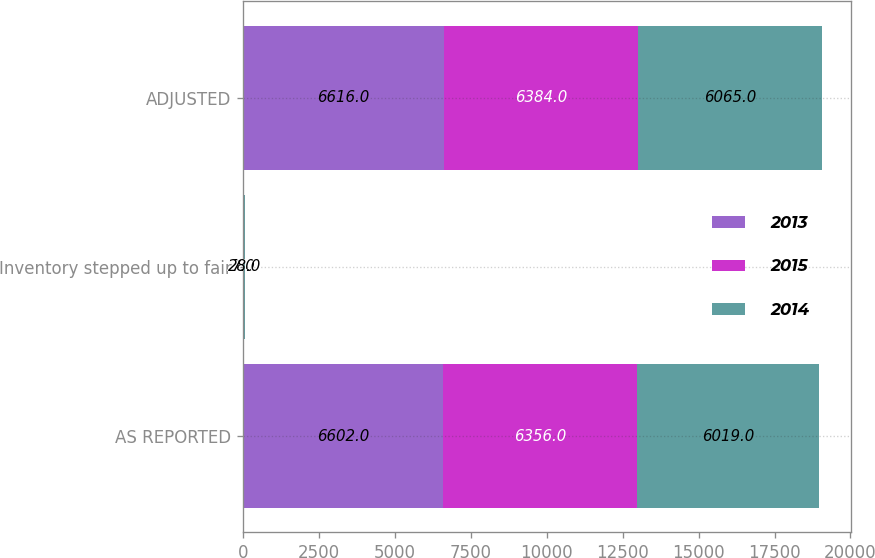Convert chart. <chart><loc_0><loc_0><loc_500><loc_500><stacked_bar_chart><ecel><fcel>AS REPORTED<fcel>Inventory stepped up to fair<fcel>ADJUSTED<nl><fcel>2013<fcel>6602<fcel>7<fcel>6616<nl><fcel>2015<fcel>6356<fcel>27<fcel>6384<nl><fcel>2014<fcel>6019<fcel>28<fcel>6065<nl></chart> 